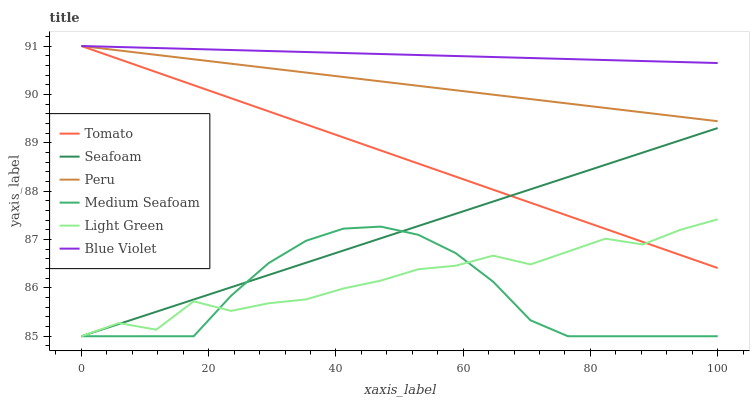Does Medium Seafoam have the minimum area under the curve?
Answer yes or no. Yes. Does Blue Violet have the maximum area under the curve?
Answer yes or no. Yes. Does Peru have the minimum area under the curve?
Answer yes or no. No. Does Peru have the maximum area under the curve?
Answer yes or no. No. Is Peru the smoothest?
Answer yes or no. Yes. Is Light Green the roughest?
Answer yes or no. Yes. Is Seafoam the smoothest?
Answer yes or no. No. Is Seafoam the roughest?
Answer yes or no. No. Does Seafoam have the lowest value?
Answer yes or no. Yes. Does Peru have the lowest value?
Answer yes or no. No. Does Blue Violet have the highest value?
Answer yes or no. Yes. Does Seafoam have the highest value?
Answer yes or no. No. Is Light Green less than Peru?
Answer yes or no. Yes. Is Peru greater than Seafoam?
Answer yes or no. Yes. Does Seafoam intersect Light Green?
Answer yes or no. Yes. Is Seafoam less than Light Green?
Answer yes or no. No. Is Seafoam greater than Light Green?
Answer yes or no. No. Does Light Green intersect Peru?
Answer yes or no. No. 